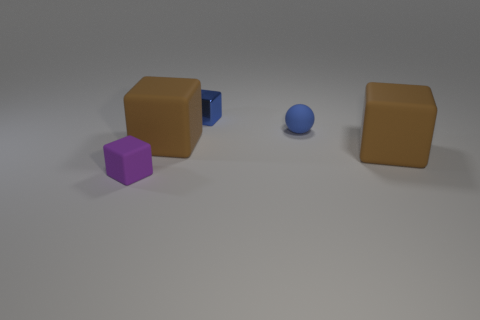What is the material of the tiny thing that is the same color as the ball?
Provide a short and direct response. Metal. Is there anything else that is the same shape as the tiny metallic thing?
Your answer should be very brief. Yes. What is the material of the tiny block that is on the right side of the tiny purple matte cube?
Offer a terse response. Metal. Are there any other things that are the same size as the blue ball?
Give a very brief answer. Yes. Are there any small matte objects to the right of the purple rubber cube?
Provide a short and direct response. Yes. There is a metal object; what shape is it?
Offer a very short reply. Cube. What number of objects are large blocks to the right of the blue shiny object or shiny cubes?
Provide a succinct answer. 2. What number of other things are the same color as the tiny metallic cube?
Ensure brevity in your answer.  1. There is a metal cube; is it the same color as the small rubber thing behind the purple rubber cube?
Your response must be concise. Yes. The tiny rubber thing that is the same shape as the metallic object is what color?
Offer a very short reply. Purple. 